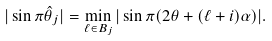Convert formula to latex. <formula><loc_0><loc_0><loc_500><loc_500>| \sin \pi \hat { \theta } _ { j } | = \min _ { \ell \in B _ { j } } | \sin \pi ( 2 \theta + ( \ell + i ) \alpha ) | .</formula> 